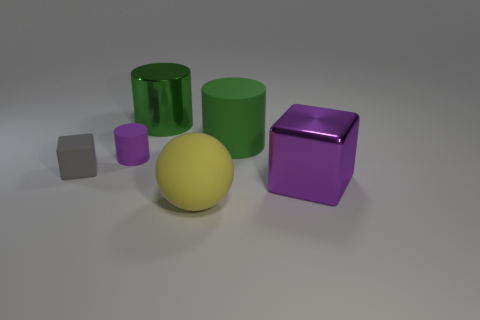Is the number of gray blocks to the right of the small block less than the number of purple shiny cubes?
Ensure brevity in your answer.  Yes. There is a purple cylinder that is the same size as the gray block; what is it made of?
Provide a short and direct response. Rubber. What size is the object that is both in front of the big green rubber cylinder and to the right of the yellow rubber sphere?
Provide a short and direct response. Large. There is a gray object that is the same shape as the large purple object; what size is it?
Provide a short and direct response. Small. How many things are either big green objects or objects that are behind the purple metal block?
Make the answer very short. 4. What is the shape of the tiny purple rubber thing?
Provide a short and direct response. Cylinder. The rubber thing behind the tiny rubber object that is behind the tiny gray thing is what shape?
Your response must be concise. Cylinder. There is a big block that is the same color as the tiny matte cylinder; what is it made of?
Your answer should be very brief. Metal. The big thing that is made of the same material as the purple cube is what color?
Your answer should be compact. Green. Is there any other thing that has the same size as the green matte cylinder?
Ensure brevity in your answer.  Yes. 